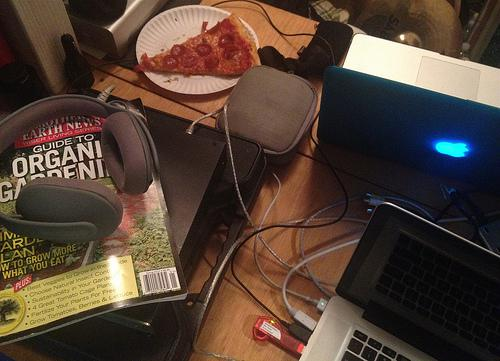Question: what color are the headphones?
Choices:
A. Grey.
B. Blue.
C. Red.
D. Green.
Answer with the letter. Answer: A Question: who is sitting at the desktop?
Choices:
A. Noone.
B. A man.
C. A girl.
D. A teenager.
Answer with the letter. Answer: A Question: what is the slice of pizza on?
Choices:
A. A napkin.
B. A hand.
C. A white plate.
D. A table.
Answer with the letter. Answer: C Question: where are the headphones?
Choices:
A. On the table.
B. In a pocket.
C. On top of a magazine.
D. On the desk.
Answer with the letter. Answer: C Question: what is the topping on the pizza?
Choices:
A. Cheese.
B. Sausage.
C. Peppers.
D. Pepperoni.
Answer with the letter. Answer: D Question: what is one thing on the desktop?
Choices:
A. A cup.
B. A phone.
C. A pen.
D. A mini laptop.
Answer with the letter. Answer: D 